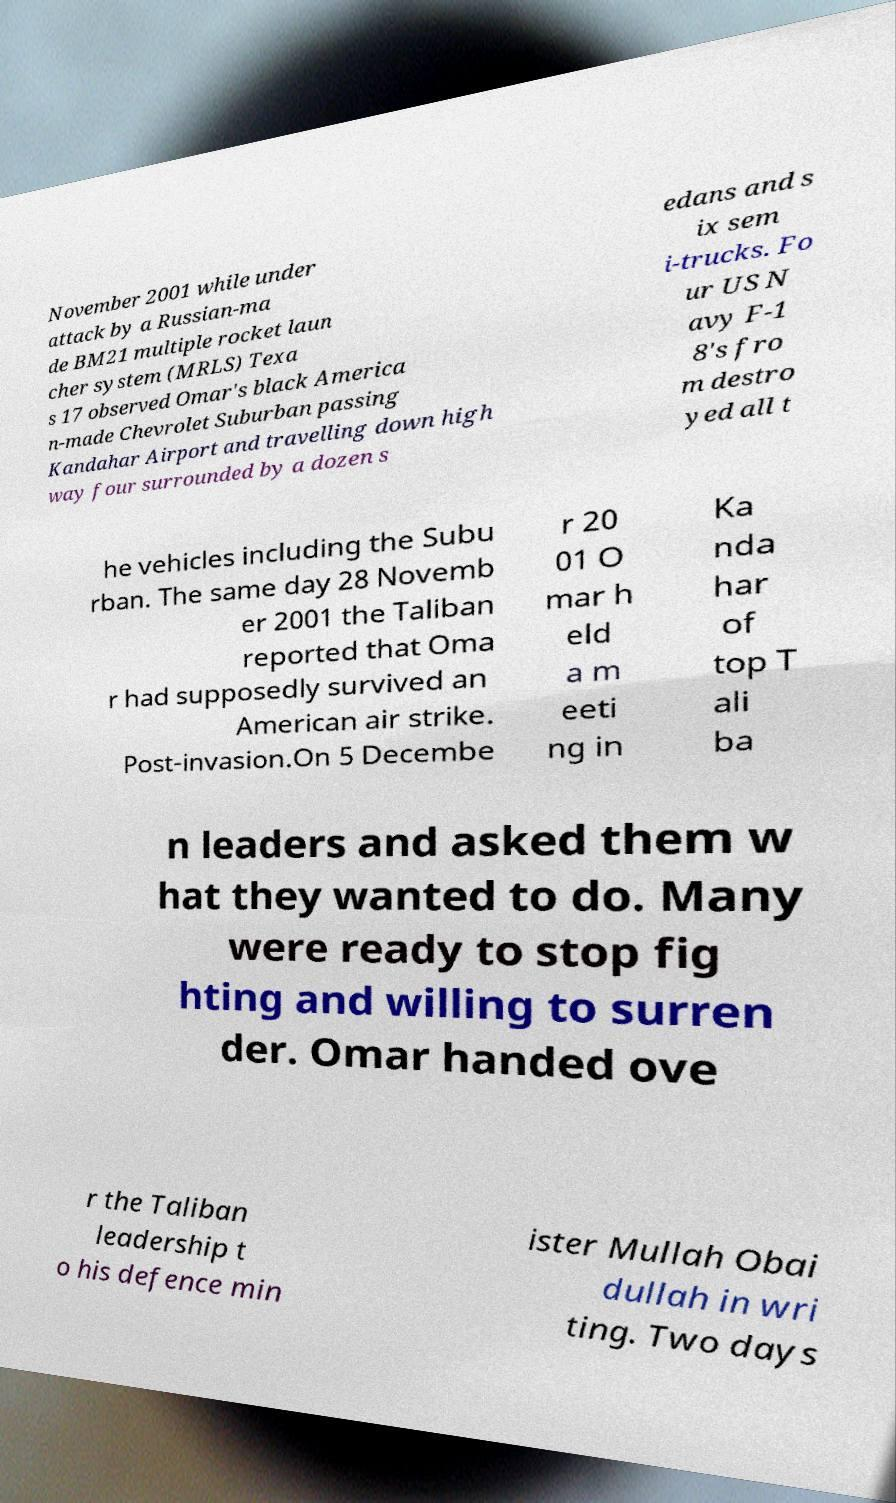Could you assist in decoding the text presented in this image and type it out clearly? November 2001 while under attack by a Russian-ma de BM21 multiple rocket laun cher system (MRLS) Texa s 17 observed Omar's black America n-made Chevrolet Suburban passing Kandahar Airport and travelling down high way four surrounded by a dozen s edans and s ix sem i-trucks. Fo ur US N avy F-1 8's fro m destro yed all t he vehicles including the Subu rban. The same day 28 Novemb er 2001 the Taliban reported that Oma r had supposedly survived an American air strike. Post-invasion.On 5 Decembe r 20 01 O mar h eld a m eeti ng in Ka nda har of top T ali ba n leaders and asked them w hat they wanted to do. Many were ready to stop fig hting and willing to surren der. Omar handed ove r the Taliban leadership t o his defence min ister Mullah Obai dullah in wri ting. Two days 